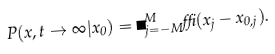Convert formula to latex. <formula><loc_0><loc_0><loc_500><loc_500>P ( x , t \rightarrow \infty | x _ { 0 } ) = \Pi _ { j = - M } ^ { M } \delta ( x _ { j } - x _ { 0 , j } ) .</formula> 